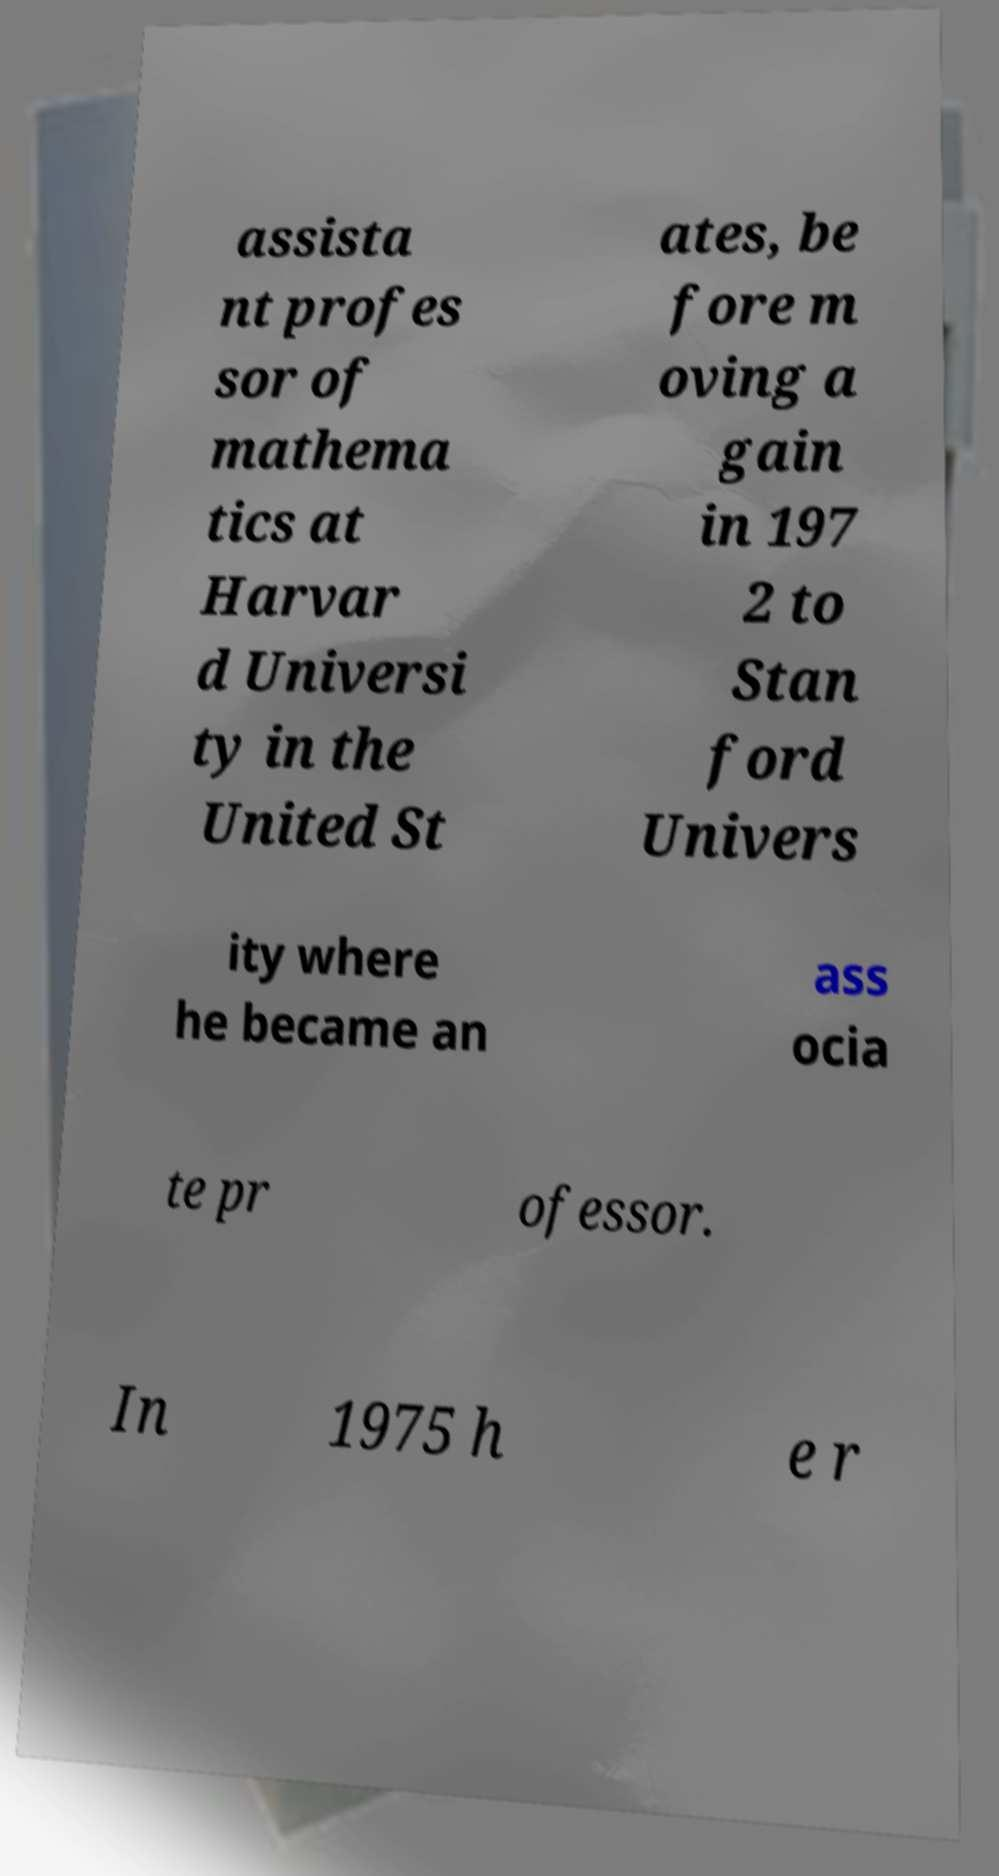Could you extract and type out the text from this image? assista nt profes sor of mathema tics at Harvar d Universi ty in the United St ates, be fore m oving a gain in 197 2 to Stan ford Univers ity where he became an ass ocia te pr ofessor. In 1975 h e r 